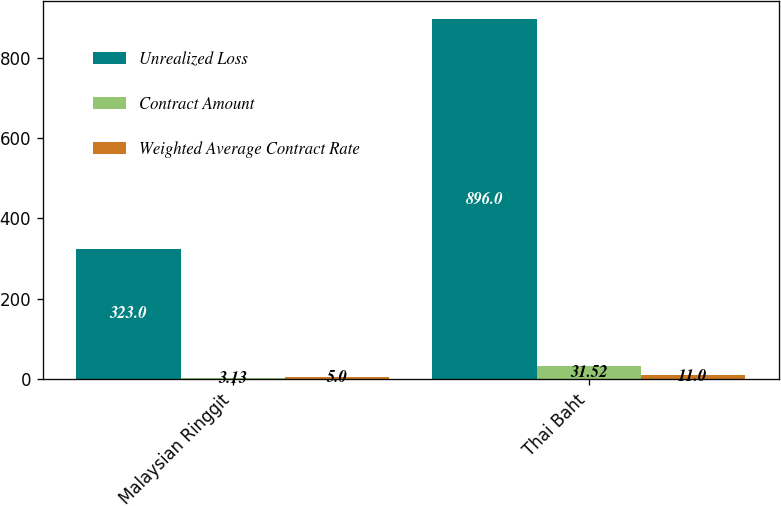Convert chart. <chart><loc_0><loc_0><loc_500><loc_500><stacked_bar_chart><ecel><fcel>Malaysian Ringgit<fcel>Thai Baht<nl><fcel>Unrealized Loss<fcel>323<fcel>896<nl><fcel>Contract Amount<fcel>3.13<fcel>31.52<nl><fcel>Weighted Average Contract Rate<fcel>5<fcel>11<nl></chart> 